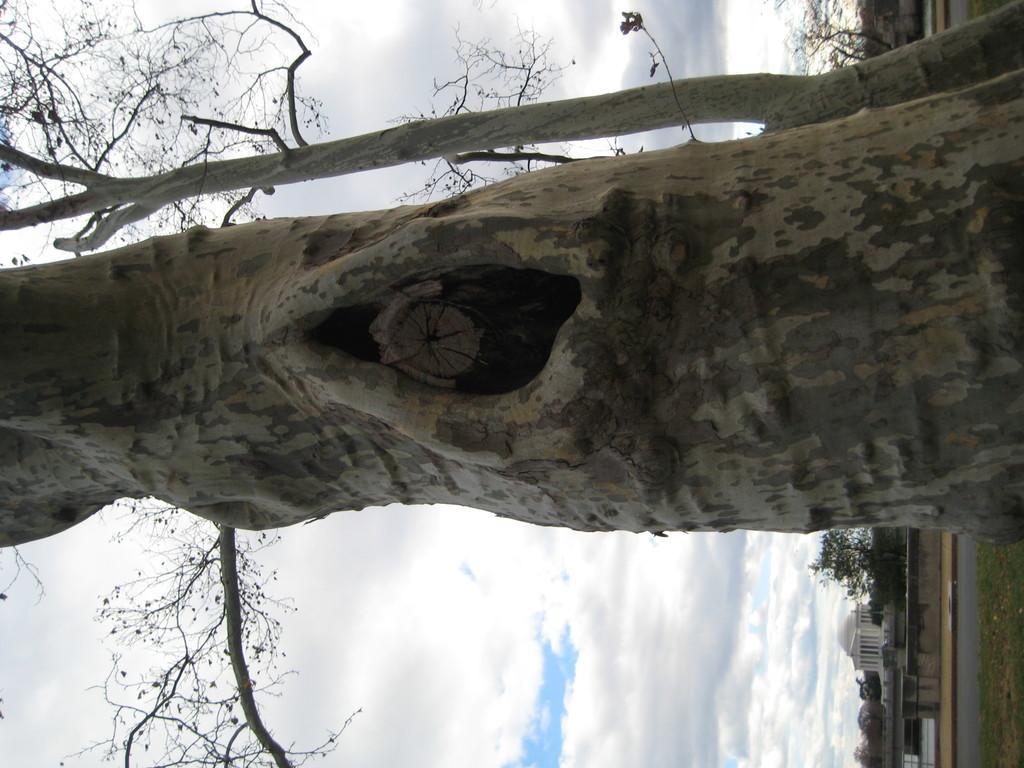Describe this image in one or two sentences. There is a tree with a hole. In the back there is another tree. There is sky with clouds. Also there are some buildings and a road. 